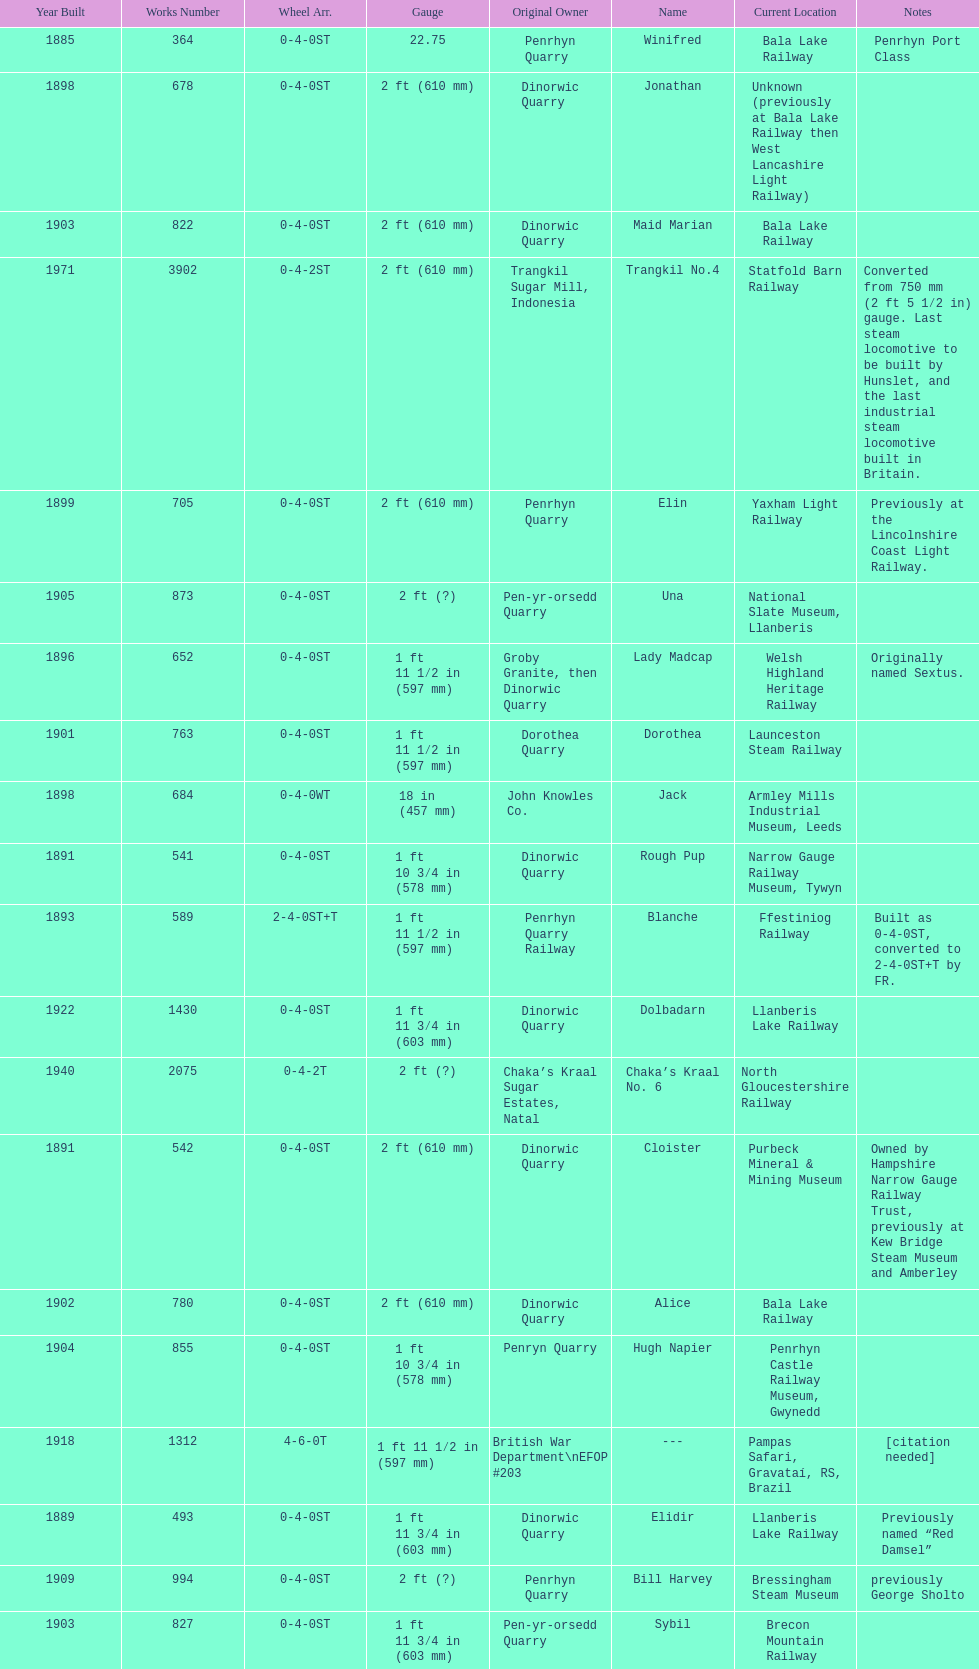In which year were the most steam locomotives built? 1898. 